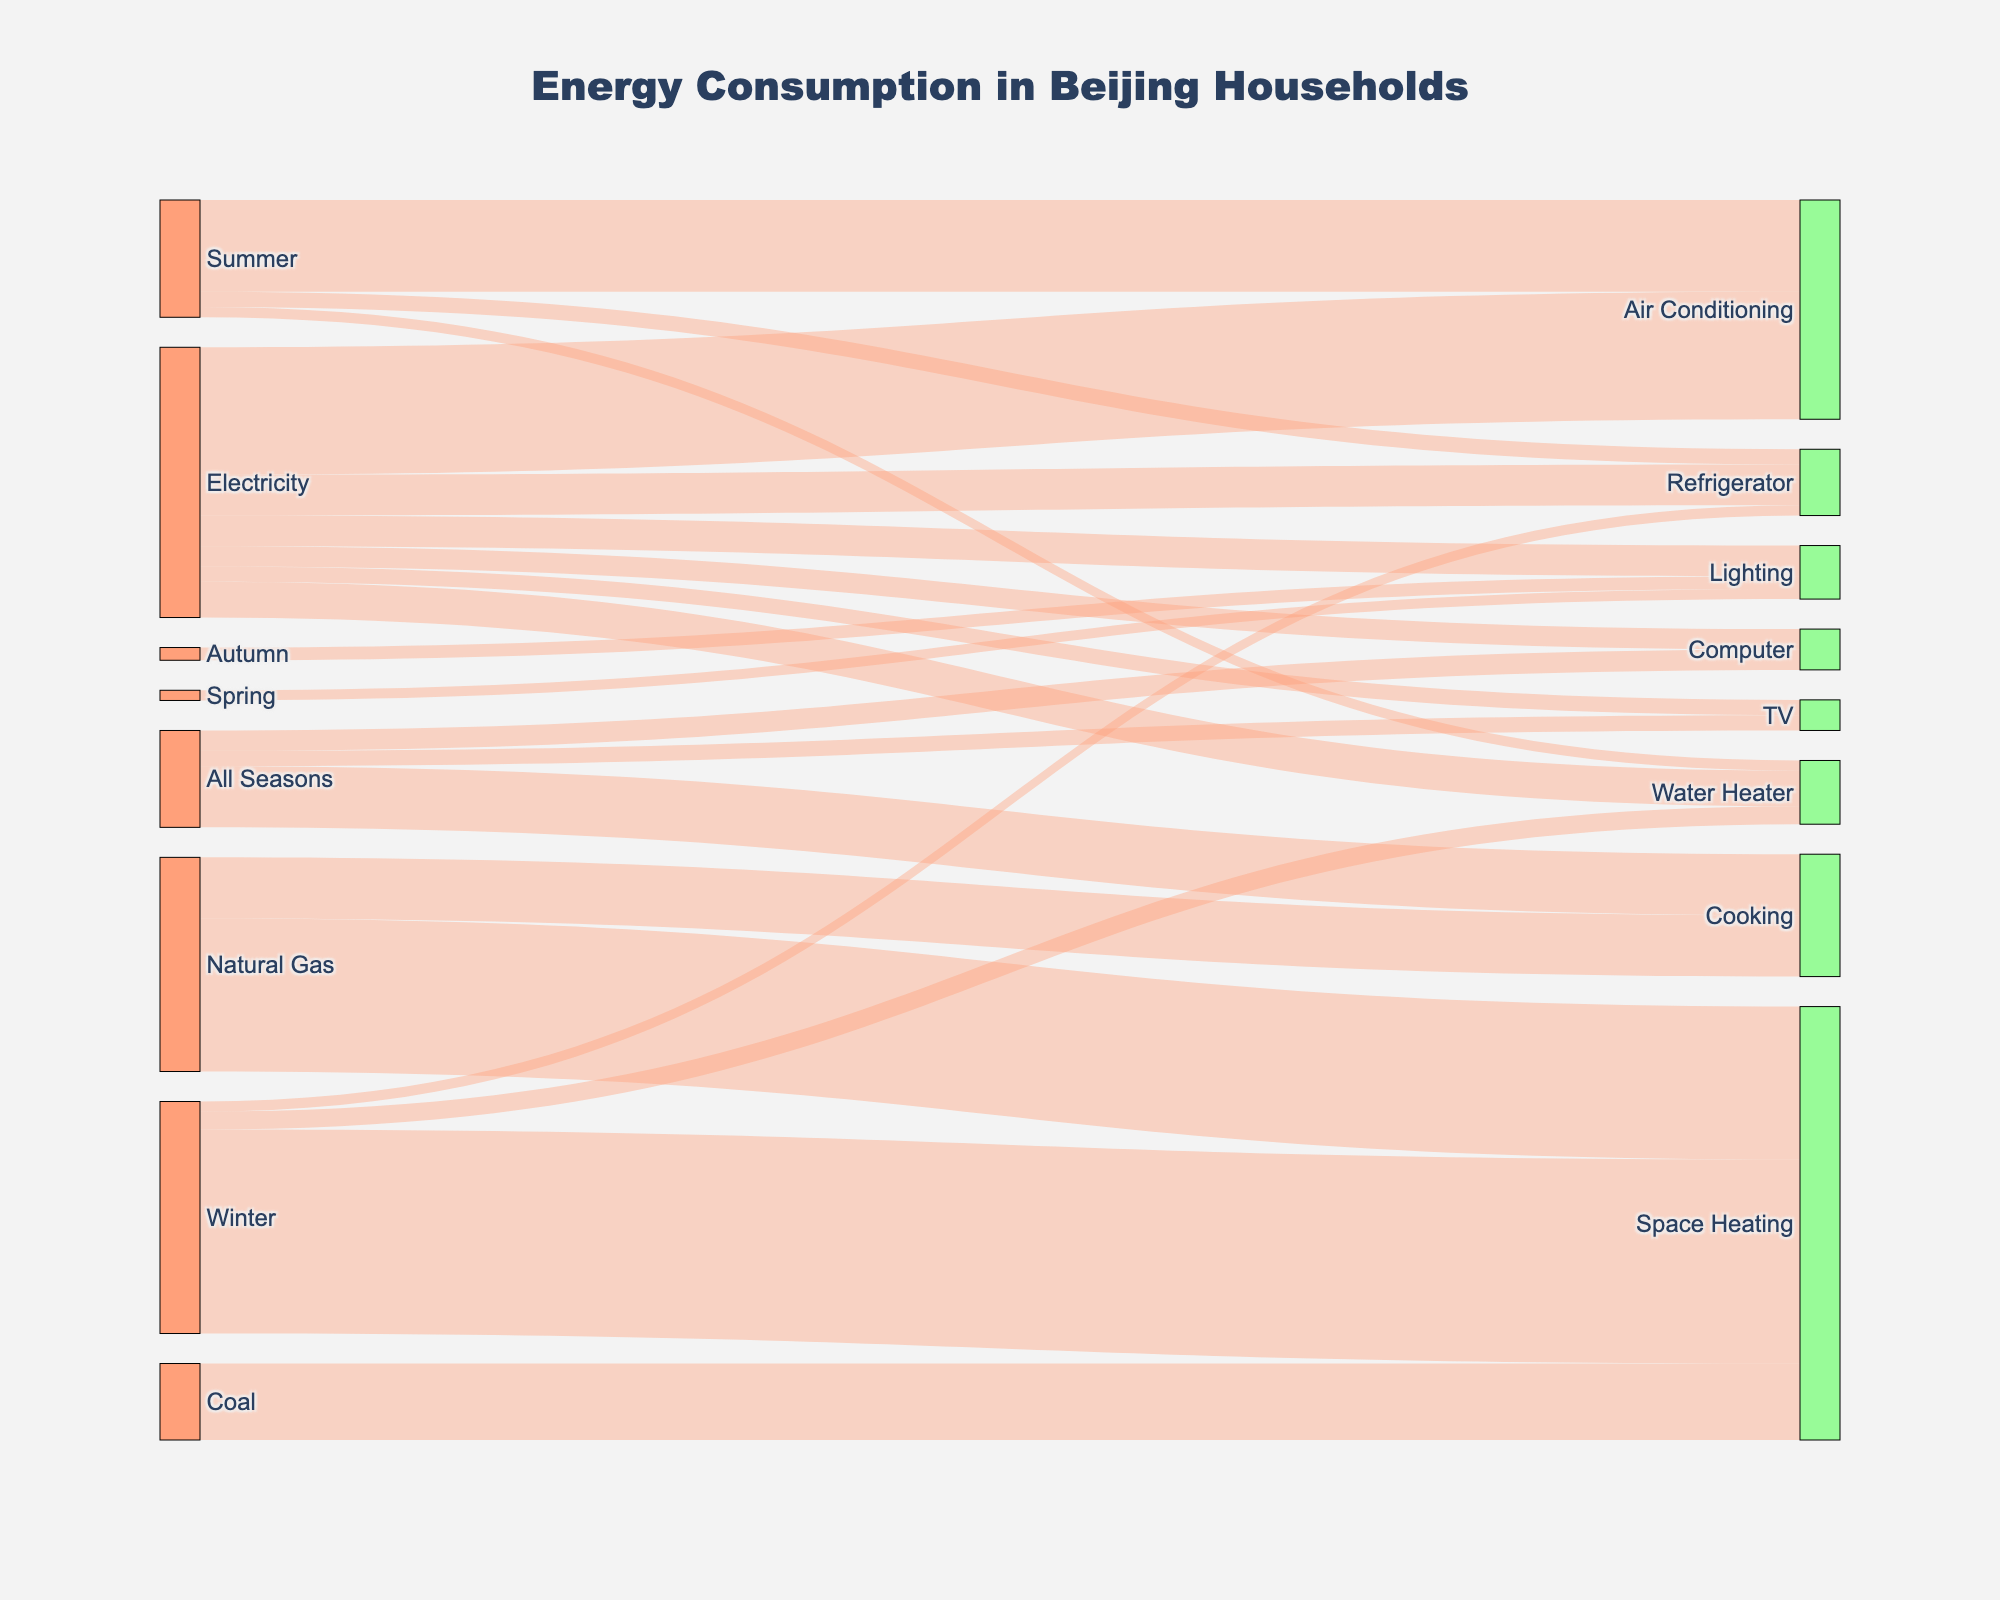What is the main title of the Sankey Diagram? The main title is prominently displayed at the top center of the diagram. It summarizes the overall content and context of the figure.
Answer: Energy Consumption in Beijing Households Which household appliance consumes the most electricity? Identify the largest value (width of the band) coming from the source "Electricity" to its targets. The widest band corresponds to the highest consumption.
Answer: Air Conditioning How does the energy consumption for space heating from natural gas compare to coal? Compare the widths of the bands from "Natural Gas" to "Space Heating" and from "Coal" to "Space Heating." The band representing natural gas is noticeably wider.
Answer: Natural Gas is higher Which season has the highest total energy consumption? Sum up the values of energy consumption for all the targets in each season. The season with the highest combined value is the answer.
Answer: Winter What color is used to represent the nodes of the target appliances? Look at the visual characteristics of the nodes grouped under the target appliances. Check their fill colors.
Answer: Light Green How much energy is consumed by water heaters in winter compared to summer? Identify the energy values for "Water Heater" in both "Winter" and "Summer" from the bands' widths. These values are explicitly labeled.
Answer: Winter: 350, Summer: 200 What is the overall consumption for cooking? Determine the total value of bands leading to "Cooking." These values are summed for the overall consumption.
Answer: 1200 Which source of energy is used for cooking? Identify the source connected to the target "Cooking." Check the bands leading to it.
Answer: Natural Gas How does electricity consumption for TV and computer compare? Compare the width of the bands from "Electricity" to "TV" and "Electricity" to "Computer." The widths and labeled values indicate their consumption.
Answer: Computer is higher What color are the bands representing energy flows? Observe the bands connecting the nodes and note their fill colors, which are consistently used to indicate energy flow.
Answer: Light Pink 